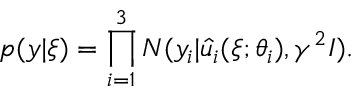<formula> <loc_0><loc_0><loc_500><loc_500>{ p ( y | \xi ) } = \prod _ { i = 1 } ^ { 3 } N ( y _ { i } | \hat { u } _ { i } ( \xi ; \theta _ { i } ) , \gamma ^ { 2 } I ) .</formula> 